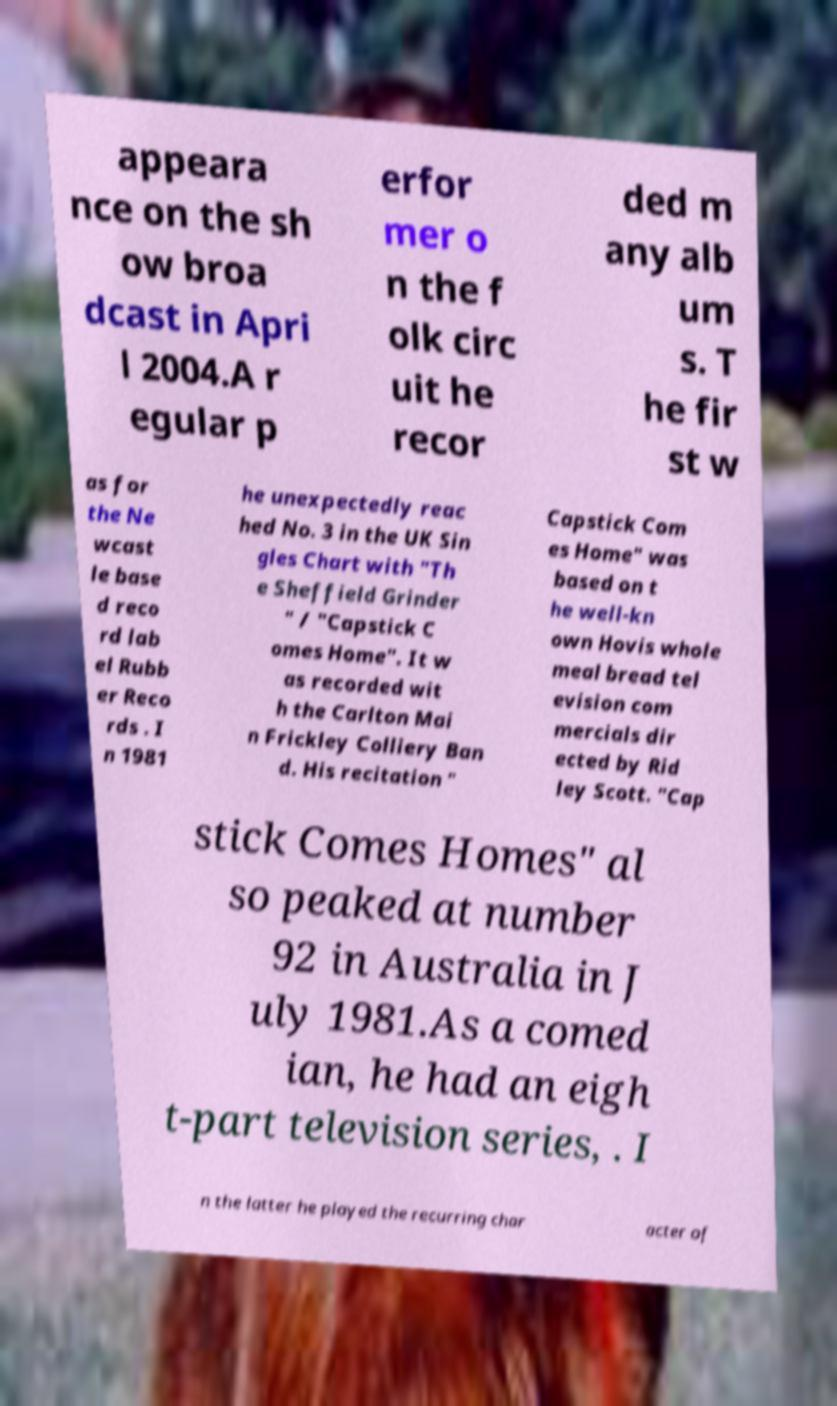Please identify and transcribe the text found in this image. appeara nce on the sh ow broa dcast in Apri l 2004.A r egular p erfor mer o n the f olk circ uit he recor ded m any alb um s. T he fir st w as for the Ne wcast le base d reco rd lab el Rubb er Reco rds . I n 1981 he unexpectedly reac hed No. 3 in the UK Sin gles Chart with "Th e Sheffield Grinder " / "Capstick C omes Home". It w as recorded wit h the Carlton Mai n Frickley Colliery Ban d. His recitation " Capstick Com es Home" was based on t he well-kn own Hovis whole meal bread tel evision com mercials dir ected by Rid ley Scott. "Cap stick Comes Homes" al so peaked at number 92 in Australia in J uly 1981.As a comed ian, he had an eigh t-part television series, . I n the latter he played the recurring char acter of 